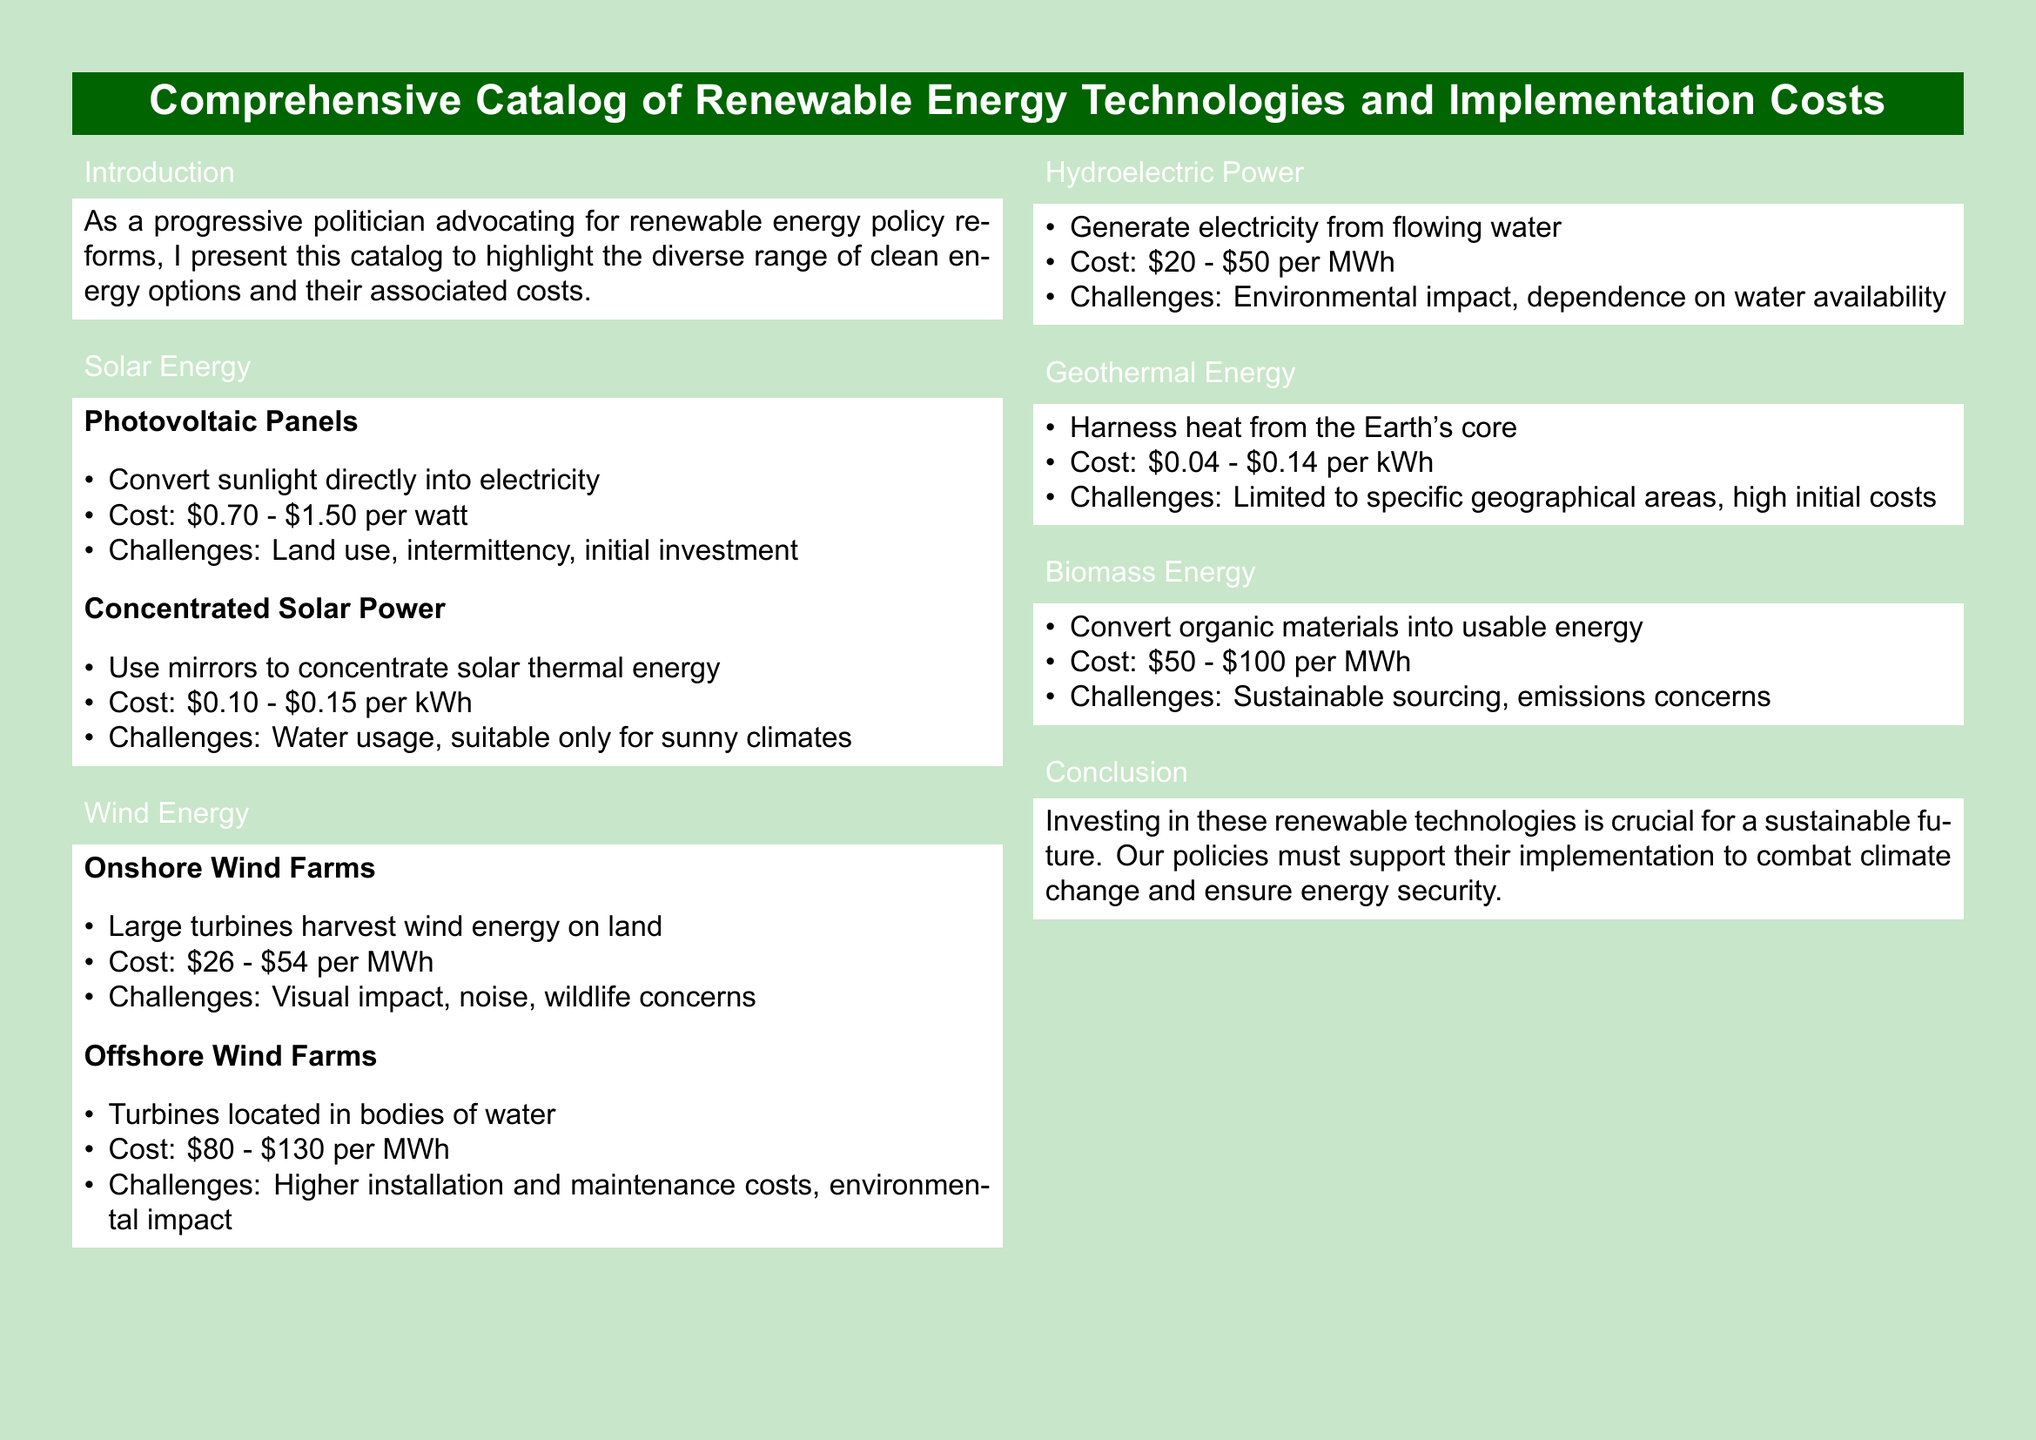What is the cost range for Photovoltaic Panels? The cost range for Photovoltaic Panels is given in the document as \$0.70 - \$1.50 per watt.
Answer: \$0.70 - \$1.50 per watt What is the main challenge of Concentrated Solar Power? The main challenge mentioned for Concentrated Solar Power is water usage, as highlighted in the document.
Answer: Water usage What is the cost of Onshore Wind Farms per MWh? The document states that Onshore Wind Farms cost \$26 - \$54 per MWh.
Answer: \$26 - \$54 per MWh Which renewable energy technology has the highest implementation cost according to the catalog? Offshore Wind Farms are listed with the highest cost range between \$80 - \$130 per MWh in the document.
Answer: Offshore Wind Farms What energy source has a cost of \$0.04 - \$0.14 per kWh? The document specifies that Geothermal Energy has a cost of \$0.04 - \$0.14 per kWh.
Answer: Geothermal Energy What is a significant environmental concern related to Biomass Energy? The document indicates that emissions concerns are a significant environmental aspect of Biomass Energy.
Answer: Emissions concerns How does Hydroelectric Power generate electricity? According to the document, Hydroelectric Power generates electricity from flowing water.
Answer: Flowing water What is the primary purpose of the catalog as stated in the introduction? The introduction of the document states that the primary purpose is to highlight clean energy options and their costs.
Answer: Highlight clean energy options and their costs What type of document is this? The structure and content of the document categorize it as a catalog focused on renewable energy technologies.
Answer: Catalog 